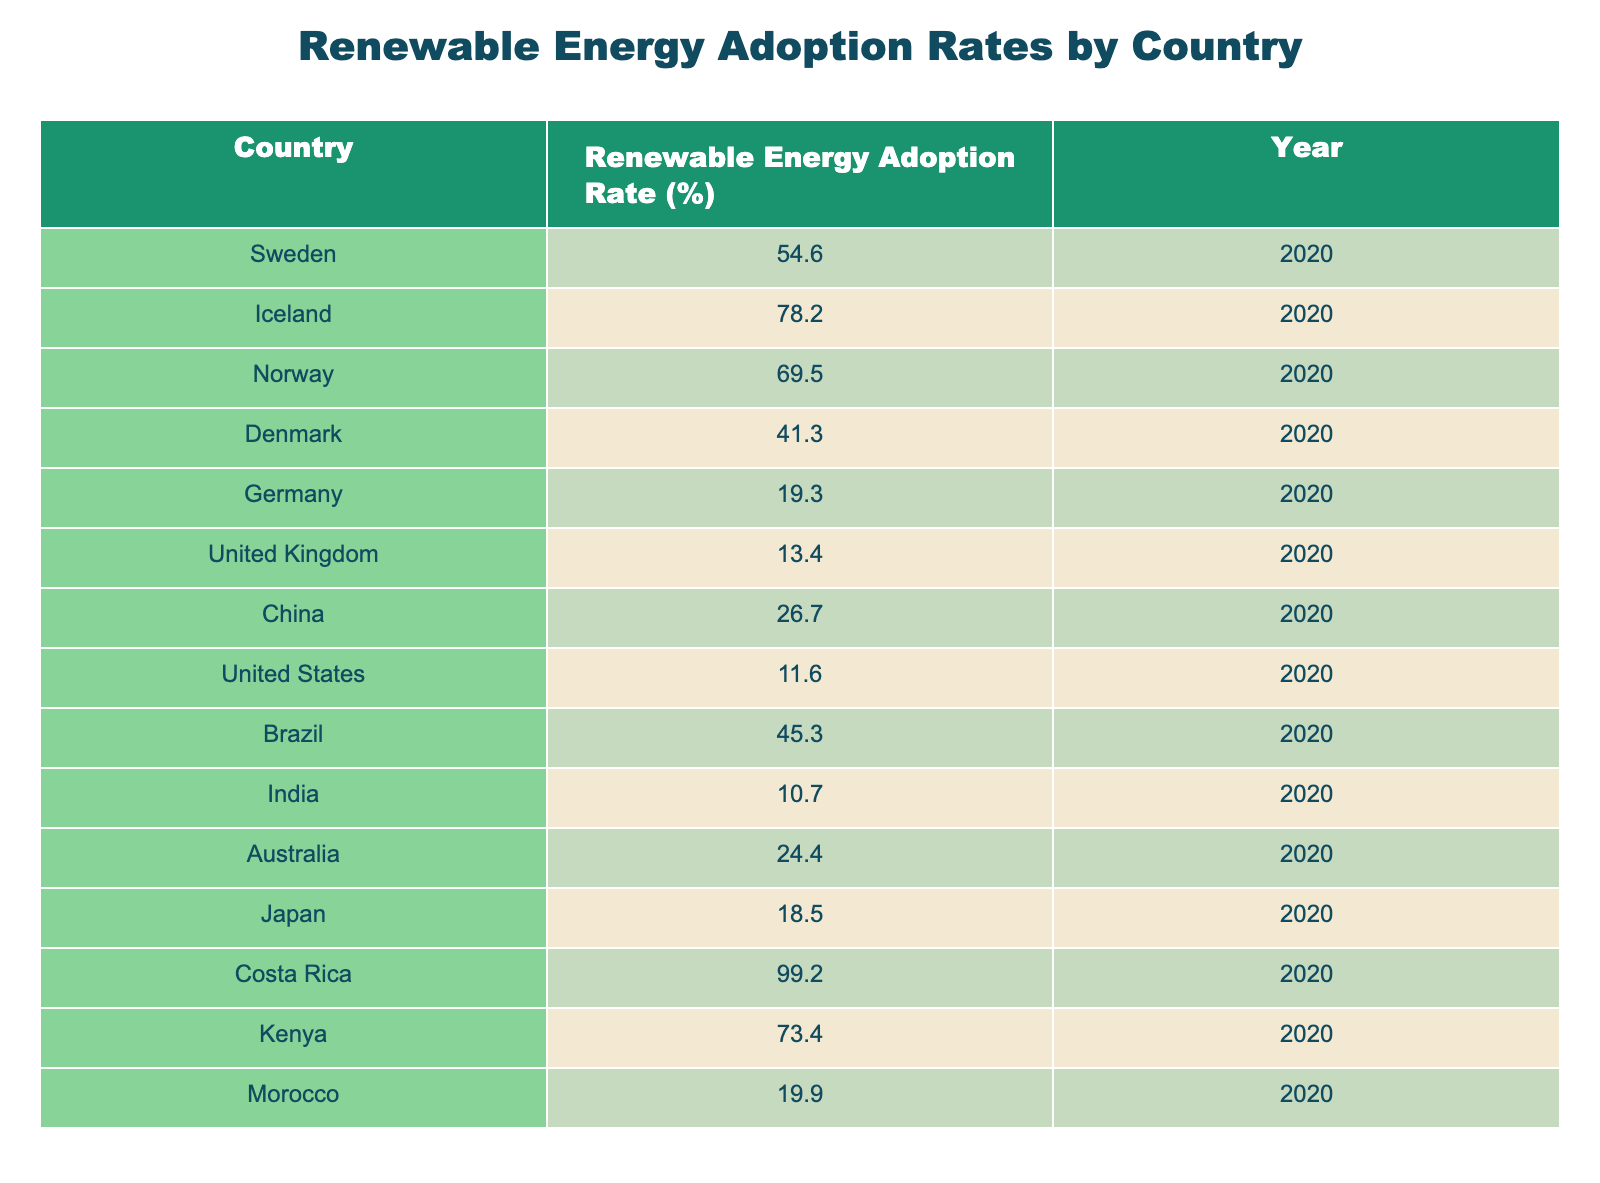What is the renewable energy adoption rate in Costa Rica? The table shows that Costa Rica has an adoption rate of 99.2% for renewable energy in 2020.
Answer: 99.2% Which country has the highest renewable energy adoption rate? By scanning through the table, it is clear that Costa Rica at 99.2% has the highest adoption rate compared to other countries listed.
Answer: Costa Rica What is the difference in renewable energy adoption rates between Sweden and the United States? Sweden's adoption rate is 54.6%, while the United States' rate is 11.6%. The difference is calculated as follows: 54.6 - 11.6 = 43.0.
Answer: 43.0 Is it true that India has a lower renewable energy adoption rate than both Germany and the United Kingdom? India has an adoption rate of 10.7%. Germany has 19.3% and the United Kingdom has 13.4%. Since 10.7% is lower than both 19.3% and 13.4%, the statement is true.
Answer: Yes What is the average renewable energy adoption rate of the top three countries by adoption rate in this table? The top three countries by adoption rate are: Costa Rica (99.2%), Iceland (78.2%), and Norway (69.5%). To find the average, we sum these rates: 99.2 + 78.2 + 69.5 = 246.9. Then divide by 3: 246.9 / 3 = 82.3.
Answer: 82.3 How many countries listed have an adoption rate of less than 20%? Checking through the table, we find Germany (19.3%), the United Kingdom (13.4%), China (26.7%), the United States (11.6%), Brazil (45.3%), India (10.7%), Australia (24.4%), Japan (18.5%), and Morocco (19.9%). Only Germany, the United Kingdom, the United States, India, and Japan have less than 20%. Thus, there are 5 countries.
Answer: 5 Which country has an adoption rate closest to 25%? By looking closer, we can see the rates that are closest to 25% are China at 26.7% and Australia at 24.4%. The closest value is Australia.
Answer: Australia What are the renewable energy adoption rates for Denmark and Brazil, and which one is higher? Denmark has a rate of 41.3%, while Brazil has a higher rate of 45.3%. Comparing the two, Brazil has the higher adoption rate.
Answer: Brazil How many countries have an adoption rate above 50%? Referring to the table, we find only Sweden (54.6%), Iceland (78.2%), Norway (69.5%), Denmark (41.3%), Brazil (45.3%), and Kenya (73.4%). Thus, Sweden, Iceland, Norway, and Kenya are above 50%, totaling 4 countries.
Answer: 4 